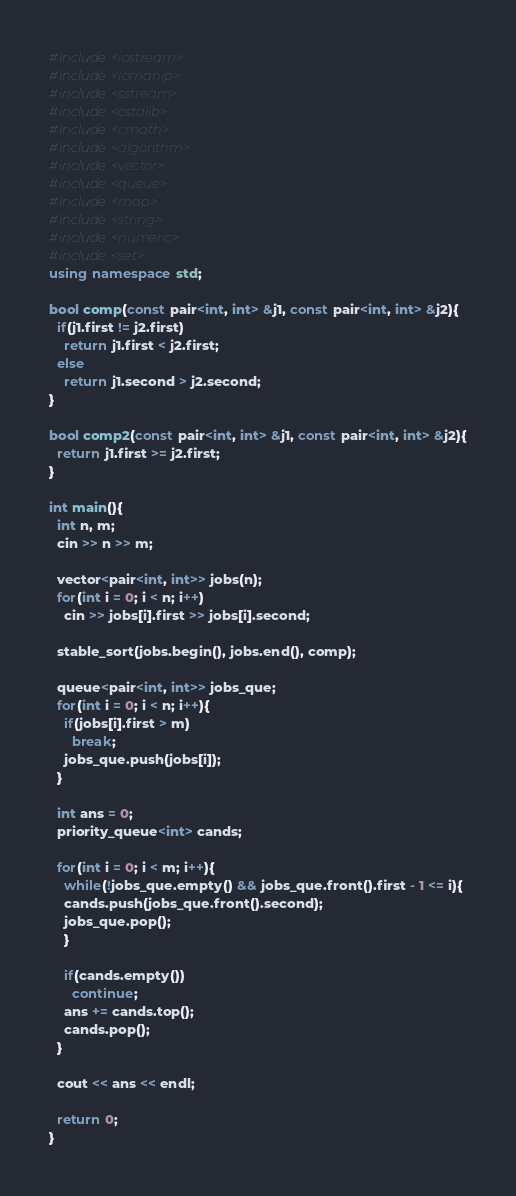Convert code to text. <code><loc_0><loc_0><loc_500><loc_500><_C++_>#include<iostream>
#include<iomanip>
#include<sstream>
#include<cstdlib>
#include<cmath>
#include<algorithm>
#include<vector>
#include<queue>
#include<map>
#include<string>
#include<numeric>
#include<set>
using namespace std;

bool comp(const pair<int, int> &j1, const pair<int, int> &j2){
  if(j1.first != j2.first)
    return j1.first < j2.first;
  else
    return j1.second > j2.second;
}

bool comp2(const pair<int, int> &j1, const pair<int, int> &j2){
  return j1.first >= j2.first;
}

int main(){
  int n, m;
  cin >> n >> m;

  vector<pair<int, int>> jobs(n);
  for(int i = 0; i < n; i++)
    cin >> jobs[i].first >> jobs[i].second;

  stable_sort(jobs.begin(), jobs.end(), comp);

  queue<pair<int, int>> jobs_que;
  for(int i = 0; i < n; i++){
    if(jobs[i].first > m)
      break;
    jobs_que.push(jobs[i]);
  }
  
  int ans = 0;
  priority_queue<int> cands;
  
  for(int i = 0; i < m; i++){
    while(!jobs_que.empty() && jobs_que.front().first - 1 <= i){
	cands.push(jobs_que.front().second);
	jobs_que.pop();
    }
    
    if(cands.empty())
      continue;
    ans += cands.top();
    cands.pop();
  }

  cout << ans << endl;
  
  return 0;
}</code> 